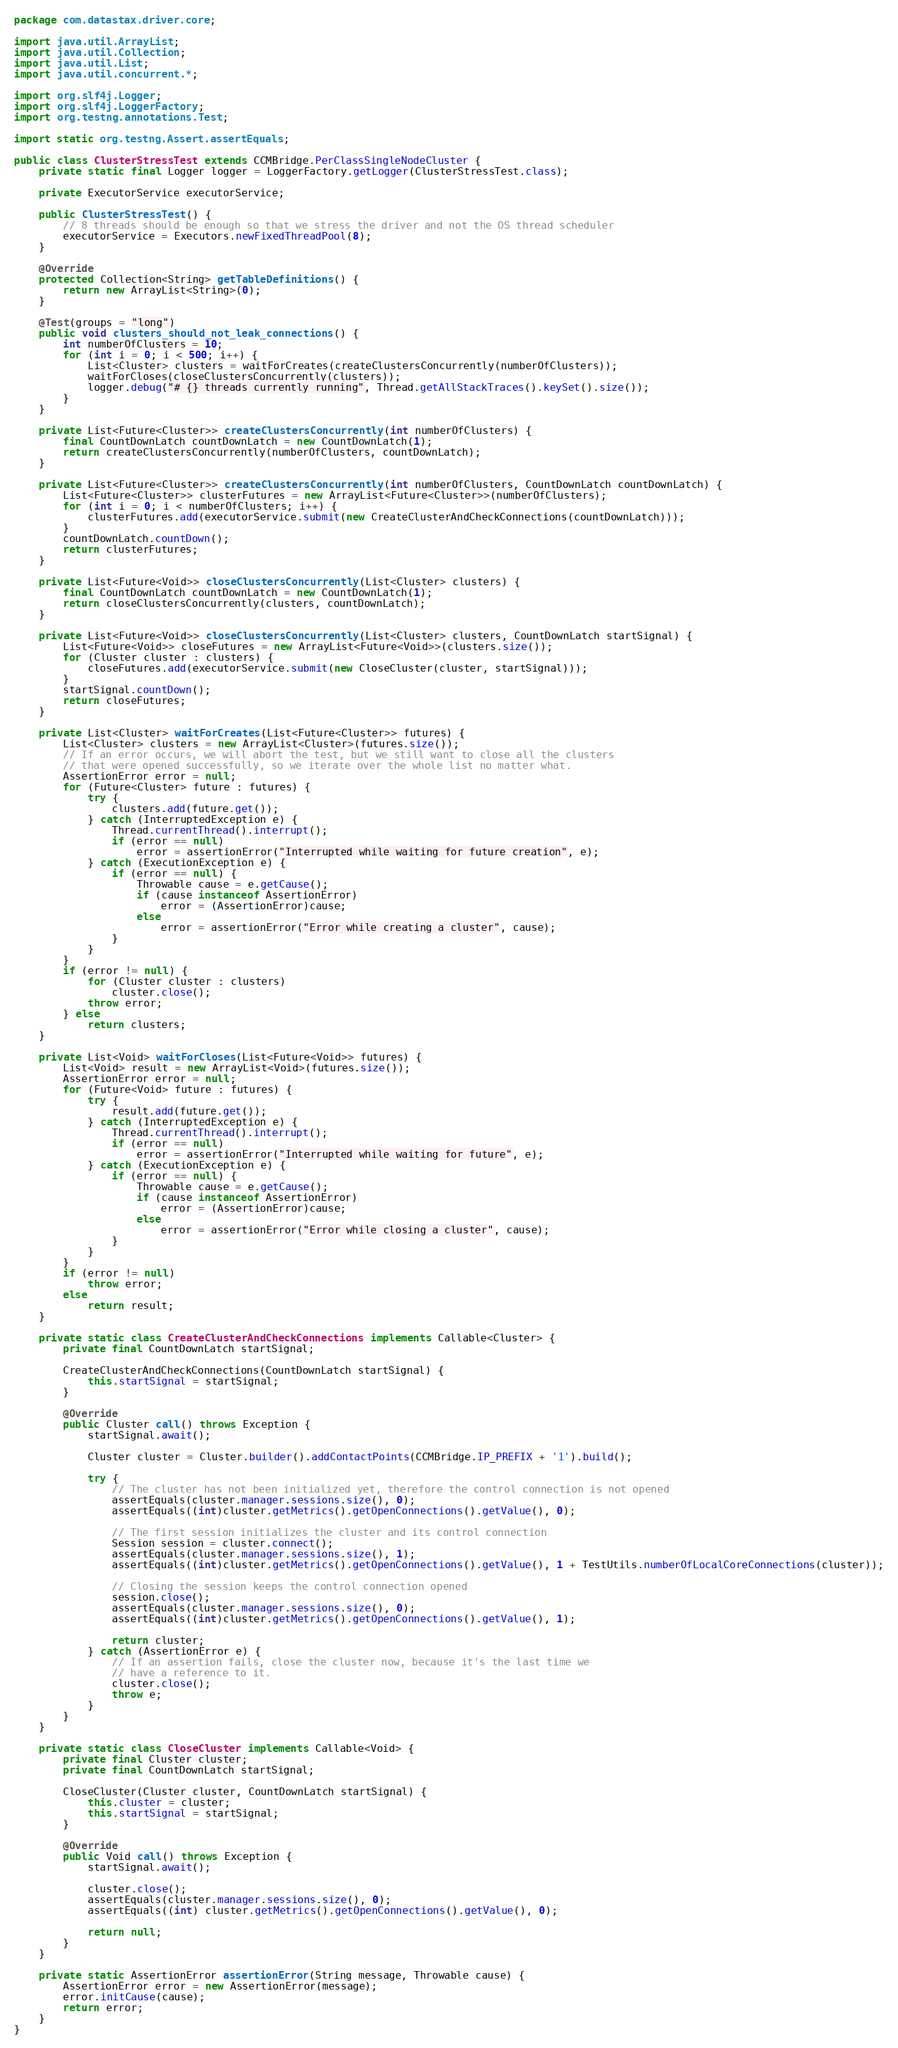<code> <loc_0><loc_0><loc_500><loc_500><_Java_>package com.datastax.driver.core;

import java.util.ArrayList;
import java.util.Collection;
import java.util.List;
import java.util.concurrent.*;

import org.slf4j.Logger;
import org.slf4j.LoggerFactory;
import org.testng.annotations.Test;

import static org.testng.Assert.assertEquals;

public class ClusterStressTest extends CCMBridge.PerClassSingleNodeCluster {
    private static final Logger logger = LoggerFactory.getLogger(ClusterStressTest.class);

    private ExecutorService executorService;

    public ClusterStressTest() {
        // 8 threads should be enough so that we stress the driver and not the OS thread scheduler
        executorService = Executors.newFixedThreadPool(8);
    }

    @Override
    protected Collection<String> getTableDefinitions() {
        return new ArrayList<String>(0);
    }

    @Test(groups = "long")
    public void clusters_should_not_leak_connections() {
        int numberOfClusters = 10;
        for (int i = 0; i < 500; i++) {
            List<Cluster> clusters = waitForCreates(createClustersConcurrently(numberOfClusters));
            waitForCloses(closeClustersConcurrently(clusters));
            logger.debug("# {} threads currently running", Thread.getAllStackTraces().keySet().size());
        }
    }

    private List<Future<Cluster>> createClustersConcurrently(int numberOfClusters) {
        final CountDownLatch countDownLatch = new CountDownLatch(1);
        return createClustersConcurrently(numberOfClusters, countDownLatch);
    }

    private List<Future<Cluster>> createClustersConcurrently(int numberOfClusters, CountDownLatch countDownLatch) {
        List<Future<Cluster>> clusterFutures = new ArrayList<Future<Cluster>>(numberOfClusters);
        for (int i = 0; i < numberOfClusters; i++) {
            clusterFutures.add(executorService.submit(new CreateClusterAndCheckConnections(countDownLatch)));
        }
        countDownLatch.countDown();
        return clusterFutures;
    }

    private List<Future<Void>> closeClustersConcurrently(List<Cluster> clusters) {
        final CountDownLatch countDownLatch = new CountDownLatch(1);
        return closeClustersConcurrently(clusters, countDownLatch);
    }

    private List<Future<Void>> closeClustersConcurrently(List<Cluster> clusters, CountDownLatch startSignal) {
        List<Future<Void>> closeFutures = new ArrayList<Future<Void>>(clusters.size());
        for (Cluster cluster : clusters) {
            closeFutures.add(executorService.submit(new CloseCluster(cluster, startSignal)));
        }
        startSignal.countDown();
        return closeFutures;
    }

    private List<Cluster> waitForCreates(List<Future<Cluster>> futures) {
        List<Cluster> clusters = new ArrayList<Cluster>(futures.size());
        // If an error occurs, we will abort the test, but we still want to close all the clusters
        // that were opened successfully, so we iterate over the whole list no matter what.
        AssertionError error = null;
        for (Future<Cluster> future : futures) {
            try {
                clusters.add(future.get());
            } catch (InterruptedException e) {
                Thread.currentThread().interrupt();
                if (error == null)
                    error = assertionError("Interrupted while waiting for future creation", e);
            } catch (ExecutionException e) {
                if (error == null) {
                    Throwable cause = e.getCause();
                    if (cause instanceof AssertionError)
                        error = (AssertionError)cause;
                    else
                        error = assertionError("Error while creating a cluster", cause);
                }
            }
        }
        if (error != null) {
            for (Cluster cluster : clusters)
                cluster.close();
            throw error;
        } else
            return clusters;
    }

    private List<Void> waitForCloses(List<Future<Void>> futures) {
        List<Void> result = new ArrayList<Void>(futures.size());
        AssertionError error = null;
        for (Future<Void> future : futures) {
            try {
                result.add(future.get());
            } catch (InterruptedException e) {
                Thread.currentThread().interrupt();
                if (error == null)
                    error = assertionError("Interrupted while waiting for future", e);
            } catch (ExecutionException e) {
                if (error == null) {
                    Throwable cause = e.getCause();
                    if (cause instanceof AssertionError)
                        error = (AssertionError)cause;
                    else
                        error = assertionError("Error while closing a cluster", cause);
                }
            }
        }
        if (error != null)
            throw error;
        else
            return result;
    }

    private static class CreateClusterAndCheckConnections implements Callable<Cluster> {
        private final CountDownLatch startSignal;

        CreateClusterAndCheckConnections(CountDownLatch startSignal) {
            this.startSignal = startSignal;
        }

        @Override
        public Cluster call() throws Exception {
            startSignal.await();

            Cluster cluster = Cluster.builder().addContactPoints(CCMBridge.IP_PREFIX + '1').build();

            try {
                // The cluster has not been initialized yet, therefore the control connection is not opened
                assertEquals(cluster.manager.sessions.size(), 0);
                assertEquals((int)cluster.getMetrics().getOpenConnections().getValue(), 0);

                // The first session initializes the cluster and its control connection
                Session session = cluster.connect();
                assertEquals(cluster.manager.sessions.size(), 1);
                assertEquals((int)cluster.getMetrics().getOpenConnections().getValue(), 1 + TestUtils.numberOfLocalCoreConnections(cluster));

                // Closing the session keeps the control connection opened
                session.close();
                assertEquals(cluster.manager.sessions.size(), 0);
                assertEquals((int)cluster.getMetrics().getOpenConnections().getValue(), 1);

                return cluster;
            } catch (AssertionError e) {
                // If an assertion fails, close the cluster now, because it's the last time we
                // have a reference to it.
                cluster.close();
                throw e;
            }
        }
    }

    private static class CloseCluster implements Callable<Void> {
        private final Cluster cluster;
        private final CountDownLatch startSignal;

        CloseCluster(Cluster cluster, CountDownLatch startSignal) {
            this.cluster = cluster;
            this.startSignal = startSignal;
        }

        @Override
        public Void call() throws Exception {
            startSignal.await();

            cluster.close();
            assertEquals(cluster.manager.sessions.size(), 0);
            assertEquals((int) cluster.getMetrics().getOpenConnections().getValue(), 0);

            return null;
        }
    }

    private static AssertionError assertionError(String message, Throwable cause) {
        AssertionError error = new AssertionError(message);
        error.initCause(cause);
        return error;
    }
}
</code> 